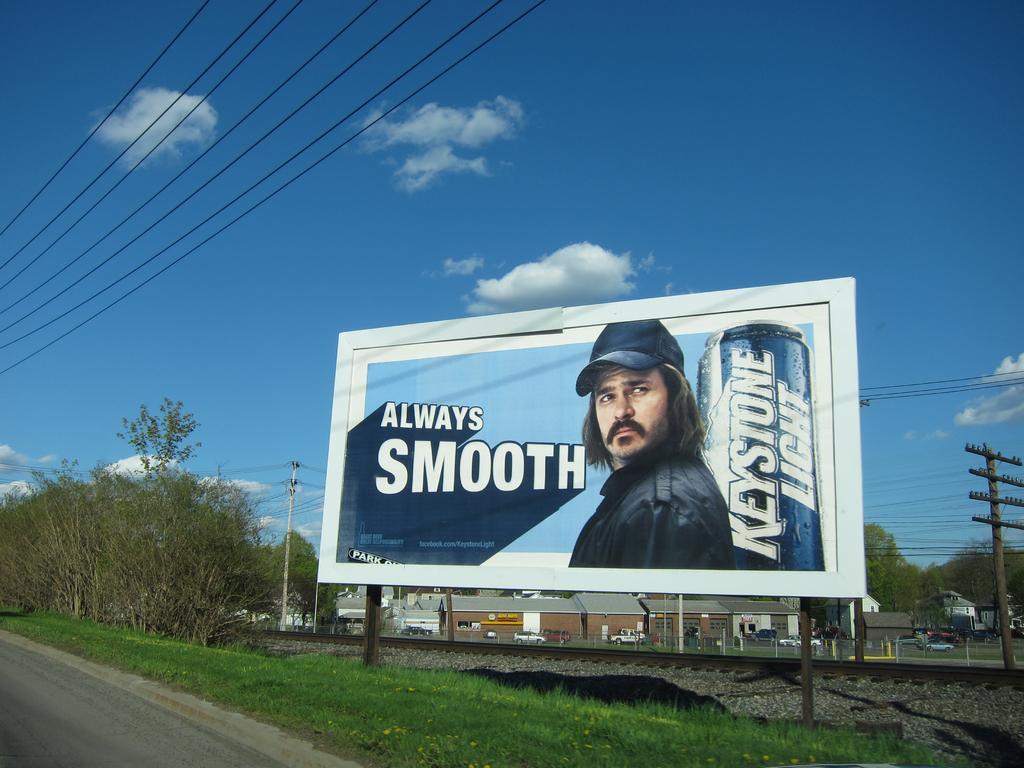Could you give a brief overview of what you see in this image? In front of the image there is a road. At the bottom of the image there is grass on the surface. There is a railway track. There are electrical poles with cables. There are trees, buildings, vehicles, poles and there is a hoarding. At the top of the image there are clouds in the sky. 